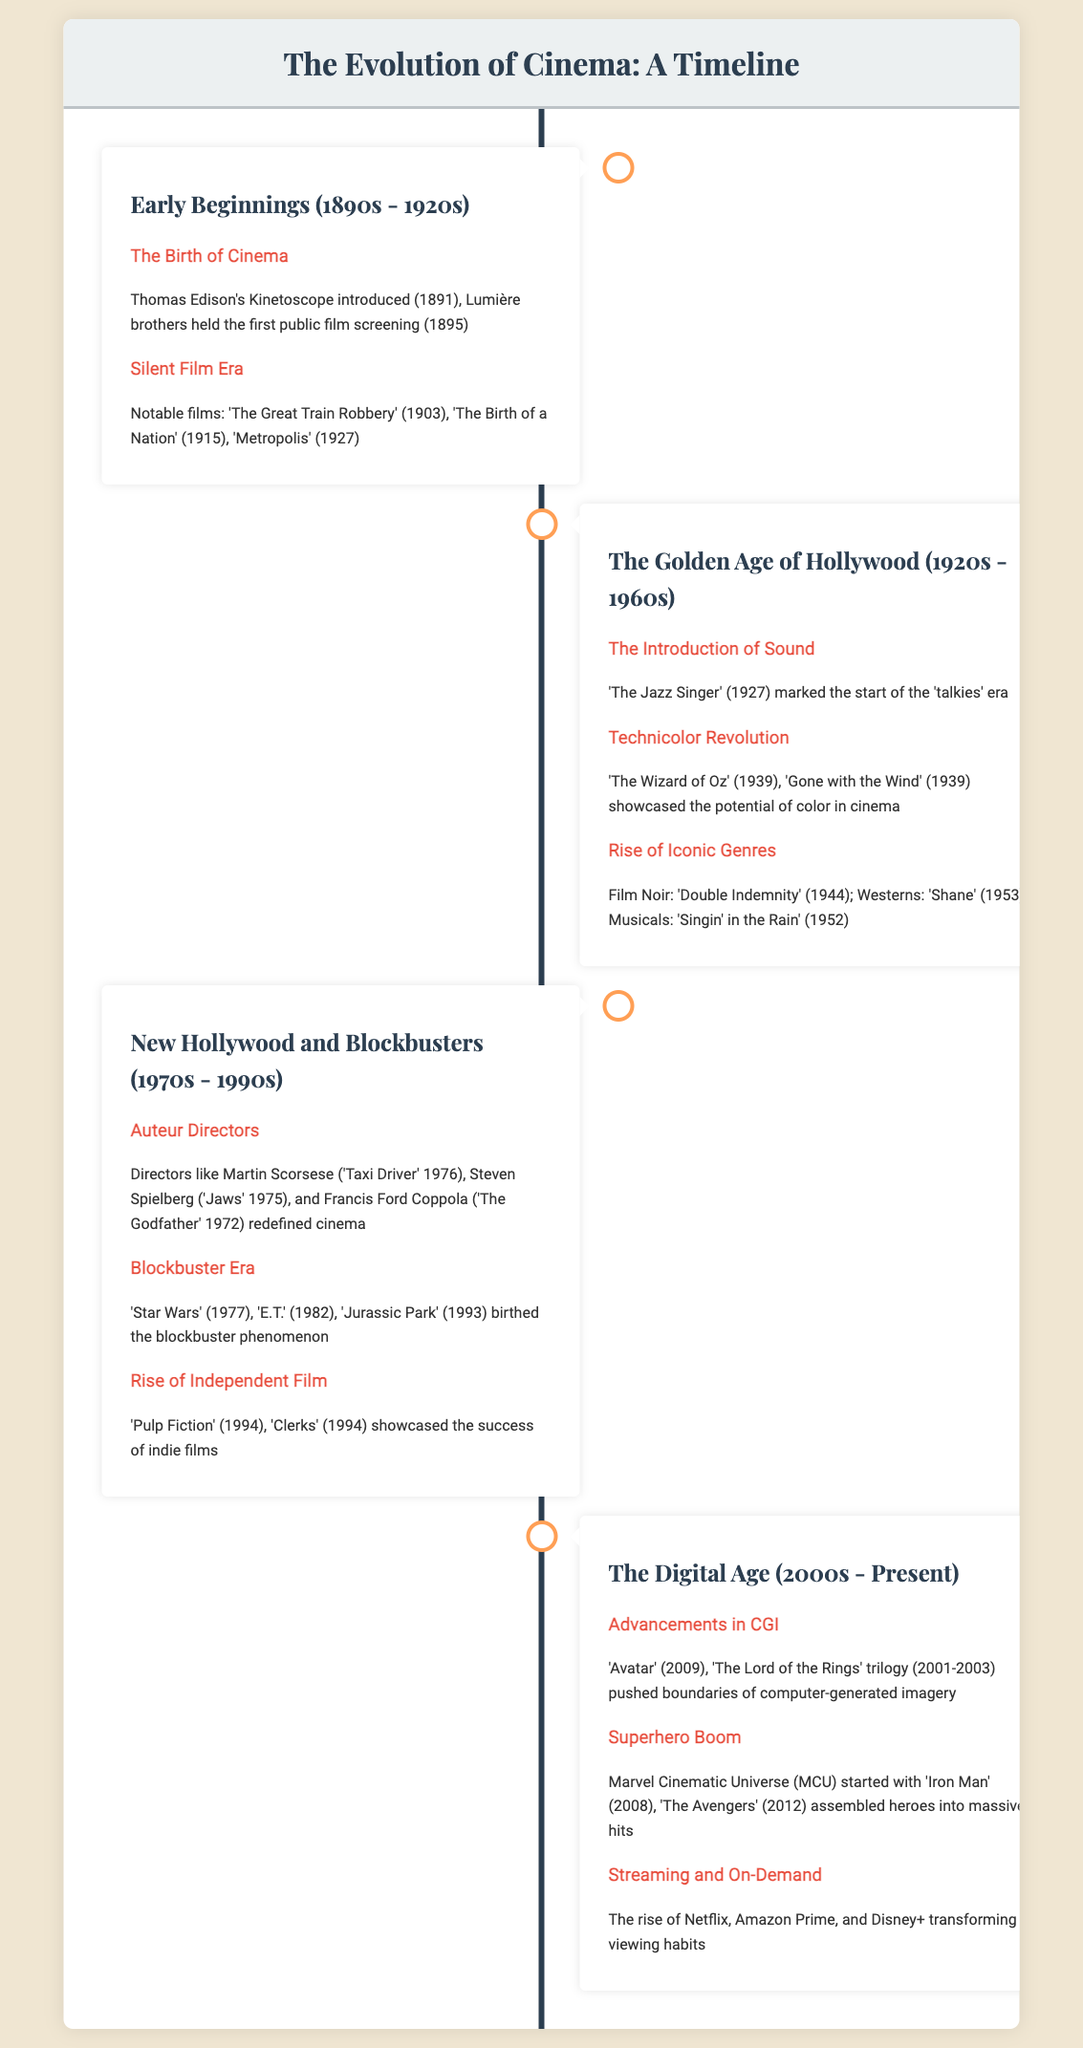What year did Thomas Edison introduce the Kinetoscope? The document states that Thomas Edison's Kinetoscope was introduced in 1891.
Answer: 1891 What film marked the start of the 'talkies' era? According to the document, 'The Jazz Singer' (1927) is noted for marking the start of the 'talkies' era.
Answer: The Jazz Singer Which iconic film was released in 1939 showcasing Technicolor? The document mentions 'The Wizard of Oz' (1939) as a film that showcased the potential of color in cinema.
Answer: The Wizard of Oz What event is signified by the release of 'Star Wars'? The document designates 'Star Wars' (1977) as a key film in the blockbuster era.
Answer: blockbuster era Which directors are listed as significant figures in the New Hollywood era? The document lists Martin Scorsese, Steven Spielberg, and Francis Ford Coppola as significant directors of that time.
Answer: Martin Scorsese, Steven Spielberg, Francis Ford Coppola What film began the Marvel Cinematic Universe? The document indicates that 'Iron Man' (2008) started the Marvel Cinematic Universe.
Answer: Iron Man Which cinematic trend emerged with the rise of streaming services? The document highlights that the rise of streaming services transformed viewing habits.
Answer: transformed viewing habits What is the time period of the Silent Film Era? The document specifies that the Silent Film Era spans from the 1900s to the 1920s.
Answer: 1900s - 1920s 